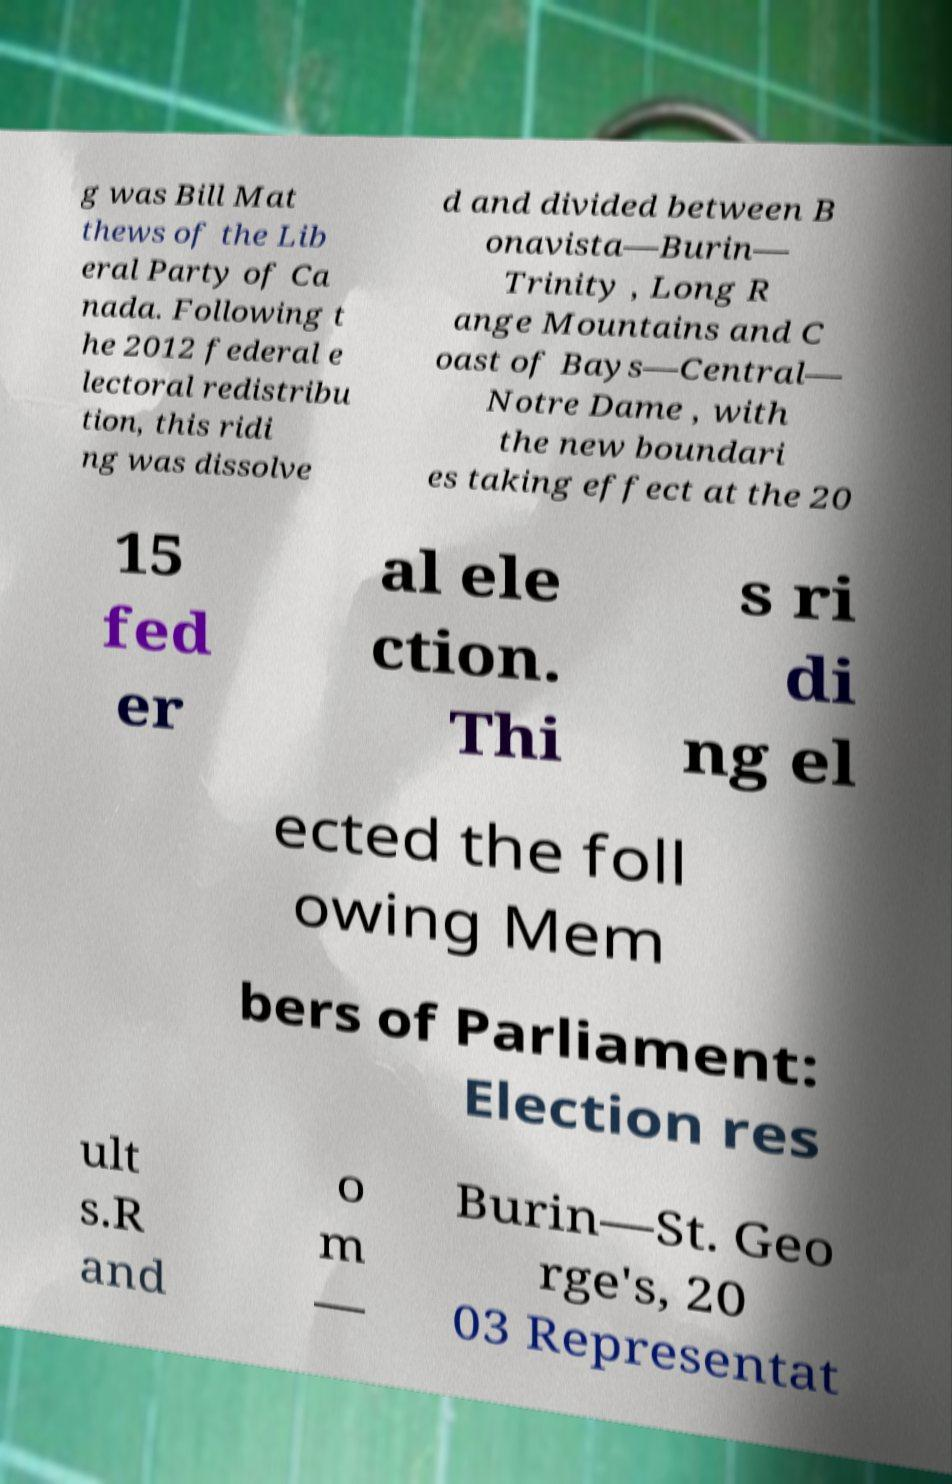Can you accurately transcribe the text from the provided image for me? g was Bill Mat thews of the Lib eral Party of Ca nada. Following t he 2012 federal e lectoral redistribu tion, this ridi ng was dissolve d and divided between B onavista—Burin— Trinity , Long R ange Mountains and C oast of Bays—Central— Notre Dame , with the new boundari es taking effect at the 20 15 fed er al ele ction. Thi s ri di ng el ected the foll owing Mem bers of Parliament: Election res ult s.R and o m — Burin—St. Geo rge's, 20 03 Representat 